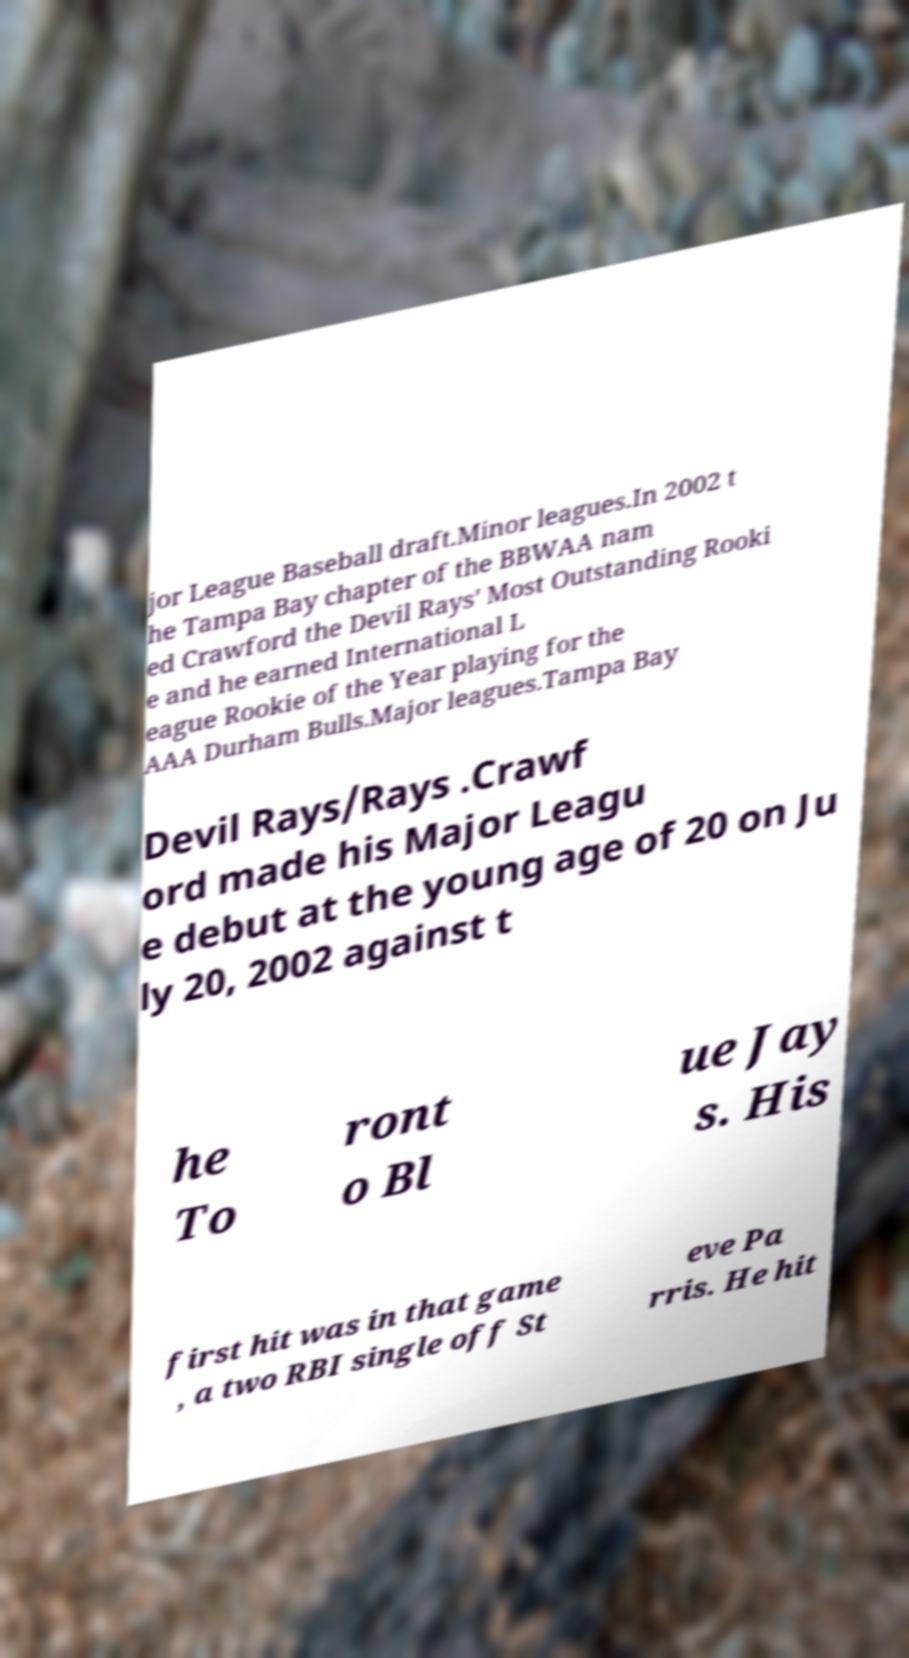There's text embedded in this image that I need extracted. Can you transcribe it verbatim? jor League Baseball draft.Minor leagues.In 2002 t he Tampa Bay chapter of the BBWAA nam ed Crawford the Devil Rays' Most Outstanding Rooki e and he earned International L eague Rookie of the Year playing for the AAA Durham Bulls.Major leagues.Tampa Bay Devil Rays/Rays .Crawf ord made his Major Leagu e debut at the young age of 20 on Ju ly 20, 2002 against t he To ront o Bl ue Jay s. His first hit was in that game , a two RBI single off St eve Pa rris. He hit 